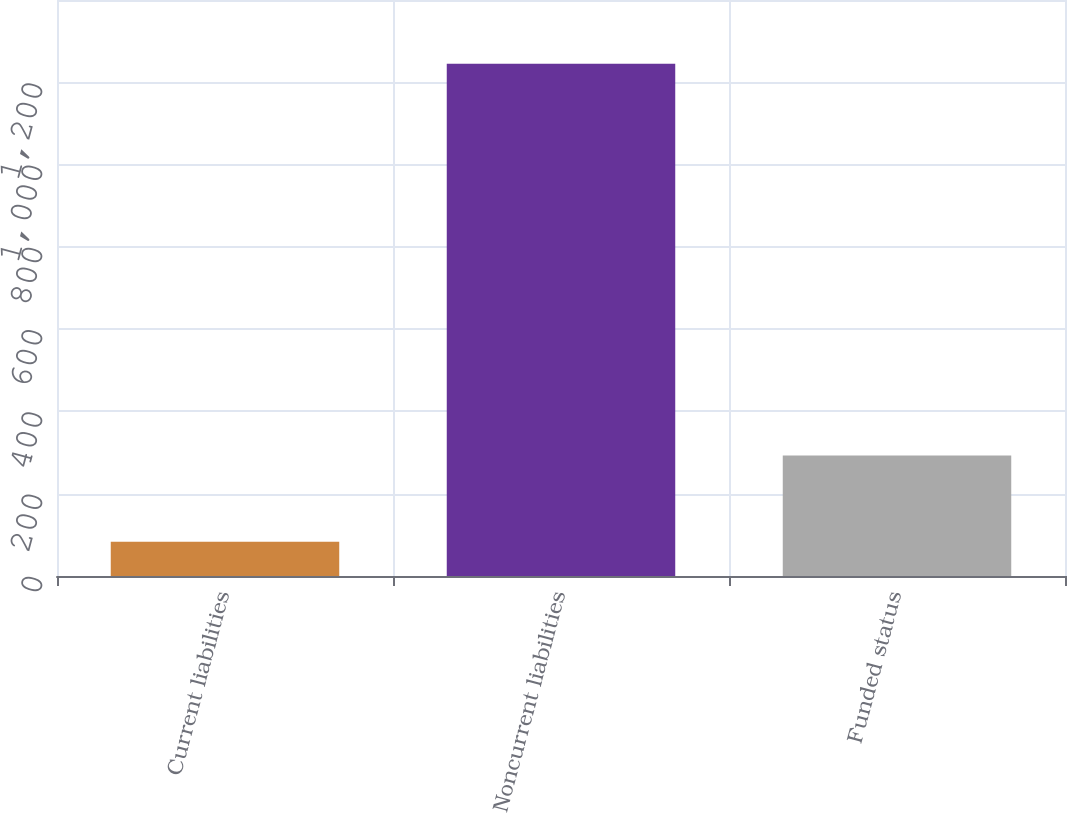<chart> <loc_0><loc_0><loc_500><loc_500><bar_chart><fcel>Current liabilities<fcel>Noncurrent liabilities<fcel>Funded status<nl><fcel>83<fcel>1245<fcel>293<nl></chart> 